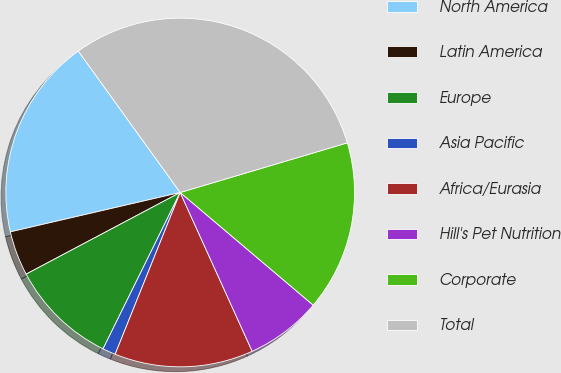Convert chart to OTSL. <chart><loc_0><loc_0><loc_500><loc_500><pie_chart><fcel>North America<fcel>Latin America<fcel>Europe<fcel>Asia Pacific<fcel>Africa/Eurasia<fcel>Hill's Pet Nutrition<fcel>Corporate<fcel>Total<nl><fcel>18.69%<fcel>4.13%<fcel>9.95%<fcel>1.21%<fcel>12.86%<fcel>7.04%<fcel>15.78%<fcel>30.34%<nl></chart> 